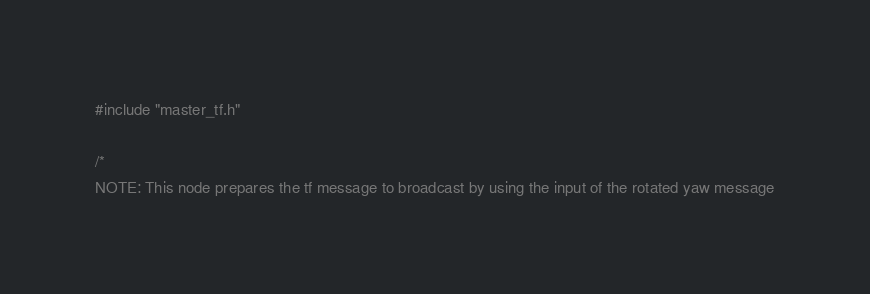<code> <loc_0><loc_0><loc_500><loc_500><_C++_>#include "master_tf.h"

/*
NOTE: This node prepares the tf message to broadcast by using the input of the rotated yaw message</code> 